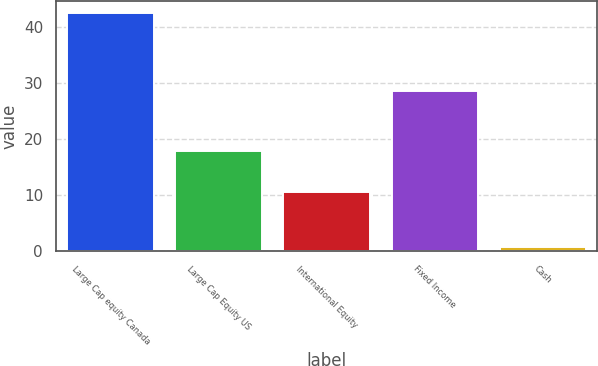Convert chart. <chart><loc_0><loc_0><loc_500><loc_500><bar_chart><fcel>Large Cap equity Canada<fcel>Large Cap Equity US<fcel>International Equity<fcel>Fixed Income<fcel>Cash<nl><fcel>42.5<fcel>17.8<fcel>10.5<fcel>28.5<fcel>0.7<nl></chart> 